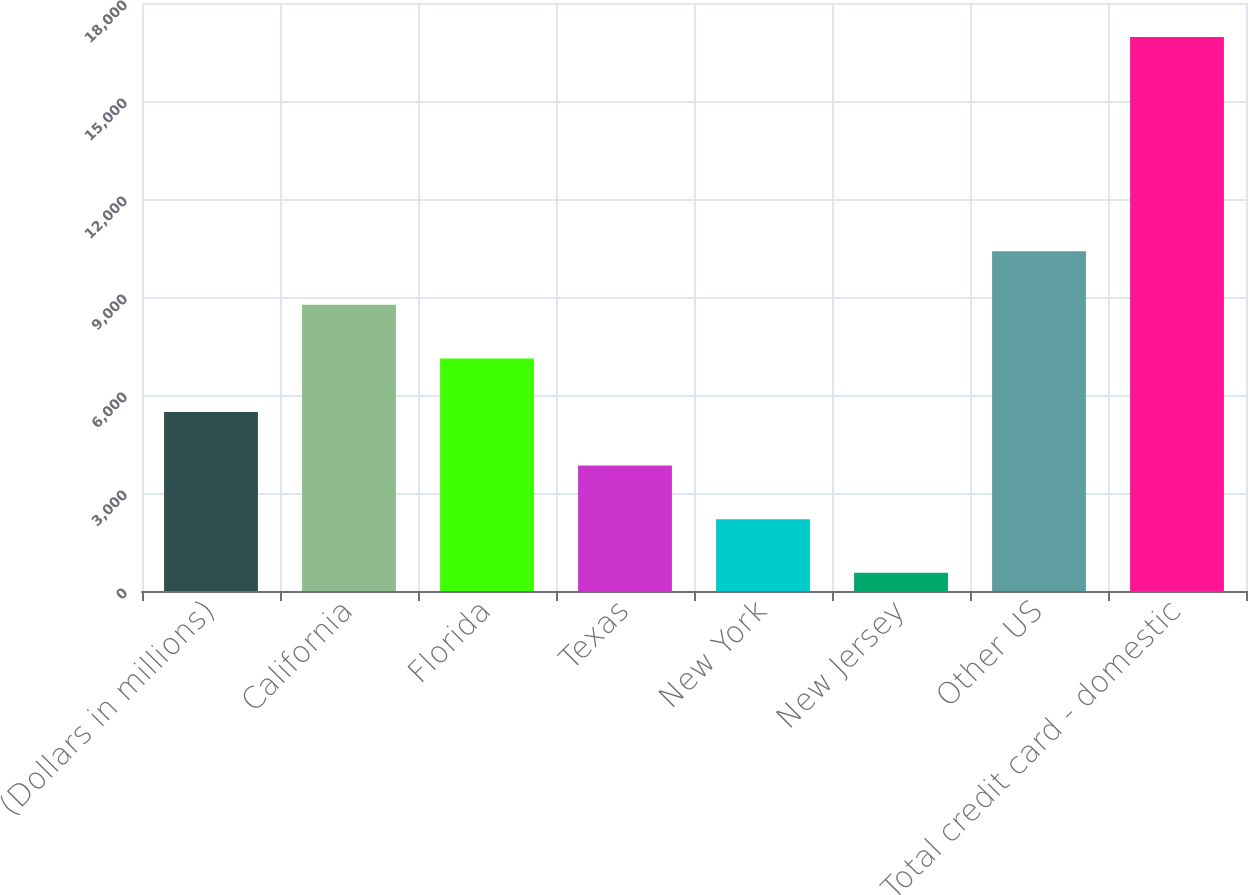Convert chart to OTSL. <chart><loc_0><loc_0><loc_500><loc_500><bar_chart><fcel>(Dollars in millions)<fcel>California<fcel>Florida<fcel>Texas<fcel>New York<fcel>New Jersey<fcel>Other US<fcel>Total credit card - domestic<nl><fcel>5479.9<fcel>8760.5<fcel>7120.2<fcel>3839.6<fcel>2199.3<fcel>559<fcel>10400.8<fcel>16962<nl></chart> 